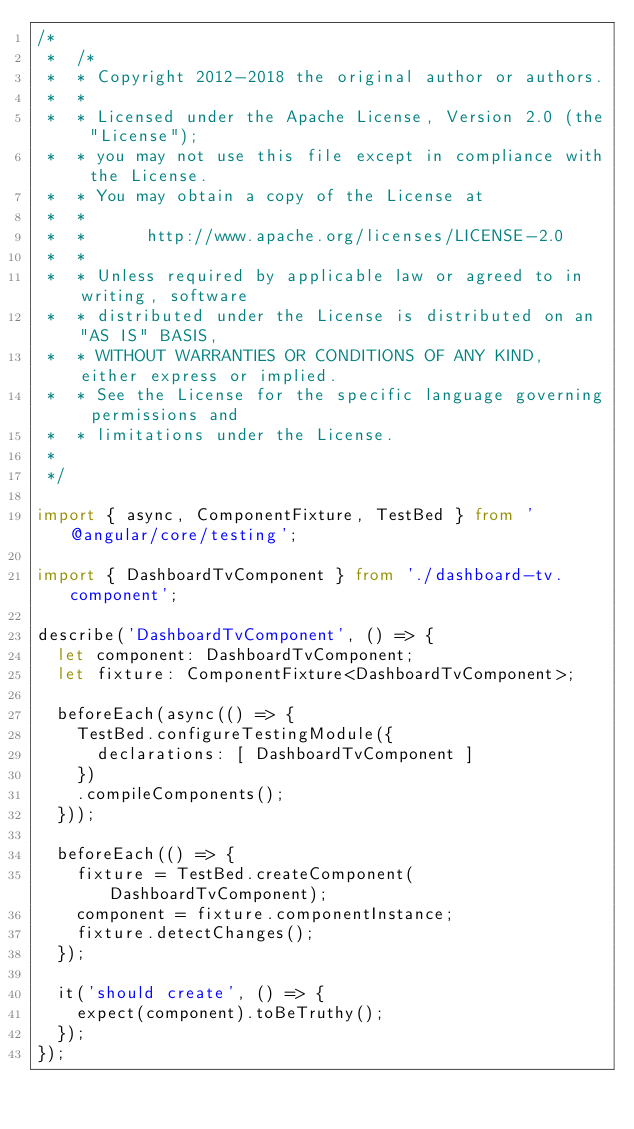<code> <loc_0><loc_0><loc_500><loc_500><_TypeScript_>/*
 *  /*
 *  * Copyright 2012-2018 the original author or authors.
 *  *
 *  * Licensed under the Apache License, Version 2.0 (the "License");
 *  * you may not use this file except in compliance with the License.
 *  * You may obtain a copy of the License at
 *  *
 *  *      http://www.apache.org/licenses/LICENSE-2.0
 *  *
 *  * Unless required by applicable law or agreed to in writing, software
 *  * distributed under the License is distributed on an "AS IS" BASIS,
 *  * WITHOUT WARRANTIES OR CONDITIONS OF ANY KIND, either express or implied.
 *  * See the License for the specific language governing permissions and
 *  * limitations under the License.
 *
 */

import { async, ComponentFixture, TestBed } from '@angular/core/testing';

import { DashboardTvComponent } from './dashboard-tv.component';

describe('DashboardTvComponent', () => {
  let component: DashboardTvComponent;
  let fixture: ComponentFixture<DashboardTvComponent>;

  beforeEach(async(() => {
    TestBed.configureTestingModule({
      declarations: [ DashboardTvComponent ]
    })
    .compileComponents();
  }));

  beforeEach(() => {
    fixture = TestBed.createComponent(DashboardTvComponent);
    component = fixture.componentInstance;
    fixture.detectChanges();
  });

  it('should create', () => {
    expect(component).toBeTruthy();
  });
});
</code> 